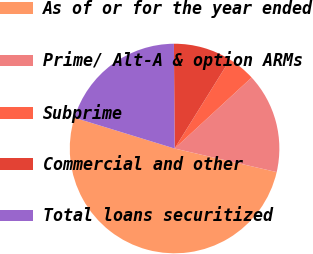Convert chart. <chart><loc_0><loc_0><loc_500><loc_500><pie_chart><fcel>As of or for the year ended<fcel>Prime/ Alt-A & option ARMs<fcel>Subprime<fcel>Commercial and other<fcel>Total loans securitized<nl><fcel>51.14%<fcel>15.46%<fcel>4.28%<fcel>8.97%<fcel>20.15%<nl></chart> 